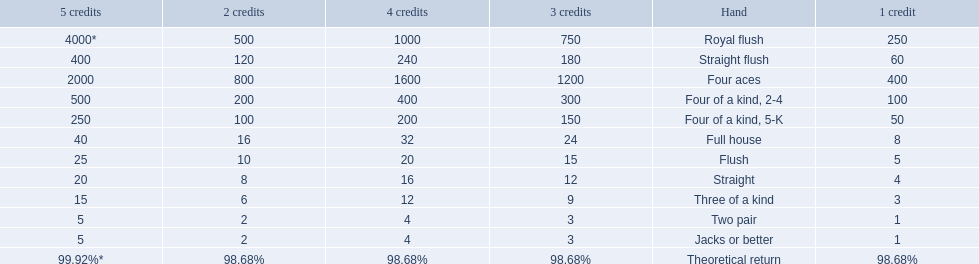Which hand is the third best hand in the card game super aces? Four aces. Which hand is the second best hand? Straight flush. Which hand had is the best hand? Royal flush. 